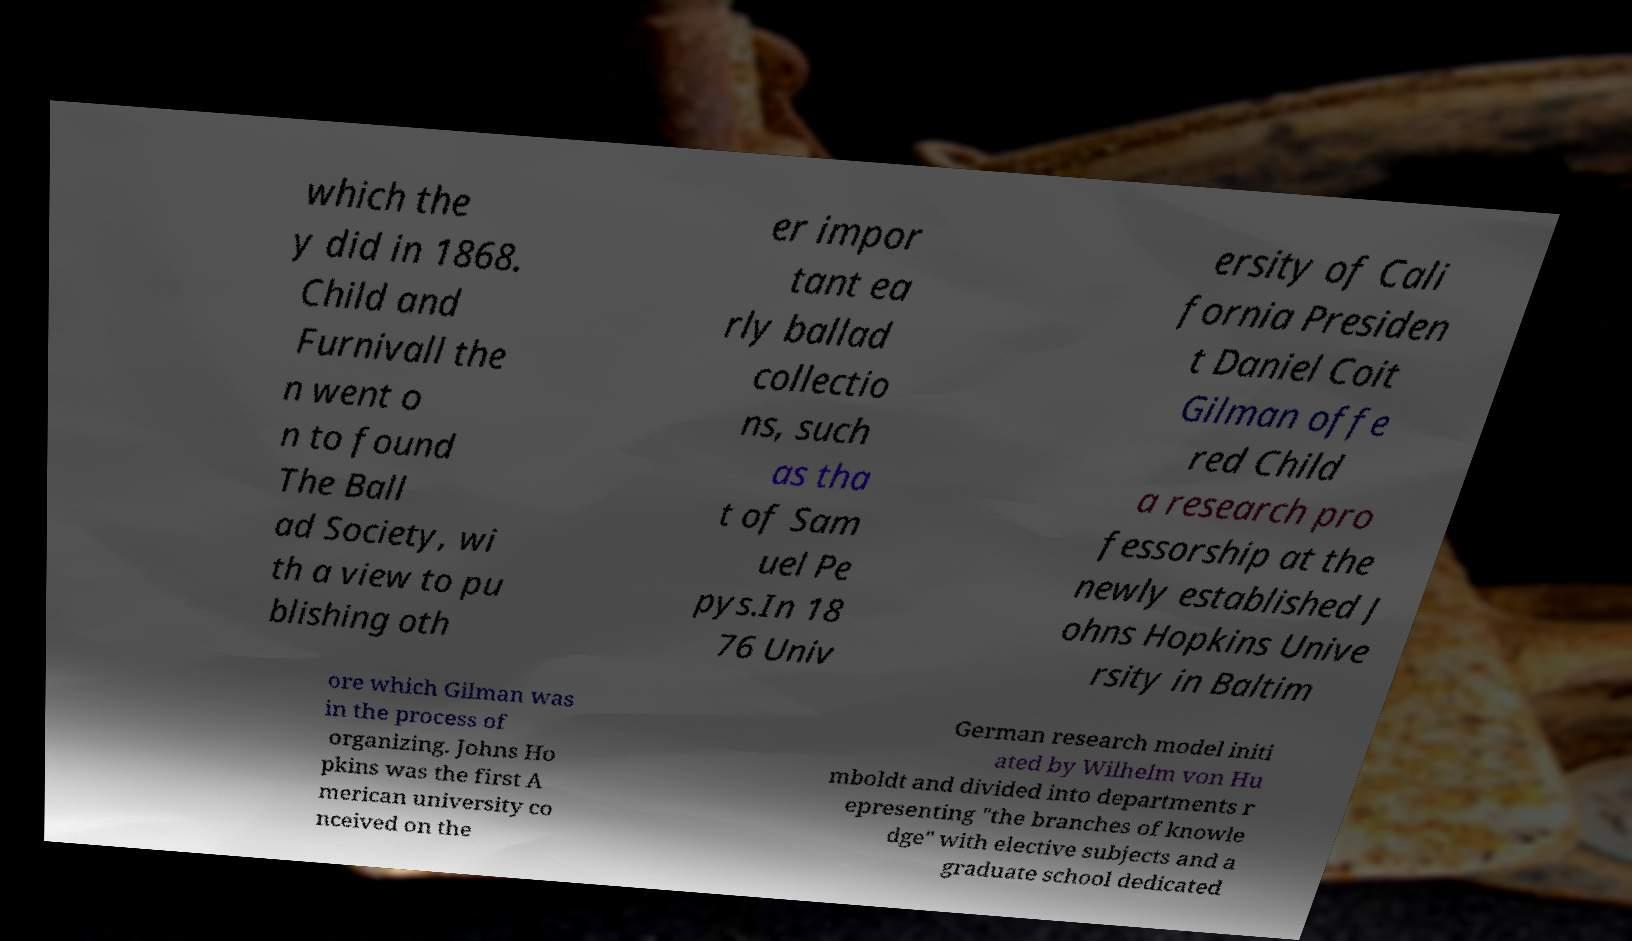Please identify and transcribe the text found in this image. which the y did in 1868. Child and Furnivall the n went o n to found The Ball ad Society, wi th a view to pu blishing oth er impor tant ea rly ballad collectio ns, such as tha t of Sam uel Pe pys.In 18 76 Univ ersity of Cali fornia Presiden t Daniel Coit Gilman offe red Child a research pro fessorship at the newly established J ohns Hopkins Unive rsity in Baltim ore which Gilman was in the process of organizing. Johns Ho pkins was the first A merican university co nceived on the German research model initi ated by Wilhelm von Hu mboldt and divided into departments r epresenting "the branches of knowle dge" with elective subjects and a graduate school dedicated 